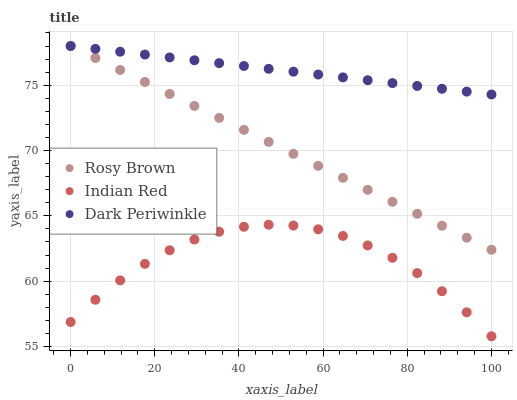Does Indian Red have the minimum area under the curve?
Answer yes or no. Yes. Does Dark Periwinkle have the maximum area under the curve?
Answer yes or no. Yes. Does Dark Periwinkle have the minimum area under the curve?
Answer yes or no. No. Does Indian Red have the maximum area under the curve?
Answer yes or no. No. Is Dark Periwinkle the smoothest?
Answer yes or no. Yes. Is Indian Red the roughest?
Answer yes or no. Yes. Is Indian Red the smoothest?
Answer yes or no. No. Is Dark Periwinkle the roughest?
Answer yes or no. No. Does Indian Red have the lowest value?
Answer yes or no. Yes. Does Dark Periwinkle have the lowest value?
Answer yes or no. No. Does Dark Periwinkle have the highest value?
Answer yes or no. Yes. Does Indian Red have the highest value?
Answer yes or no. No. Is Indian Red less than Dark Periwinkle?
Answer yes or no. Yes. Is Dark Periwinkle greater than Indian Red?
Answer yes or no. Yes. Does Rosy Brown intersect Dark Periwinkle?
Answer yes or no. Yes. Is Rosy Brown less than Dark Periwinkle?
Answer yes or no. No. Is Rosy Brown greater than Dark Periwinkle?
Answer yes or no. No. Does Indian Red intersect Dark Periwinkle?
Answer yes or no. No. 